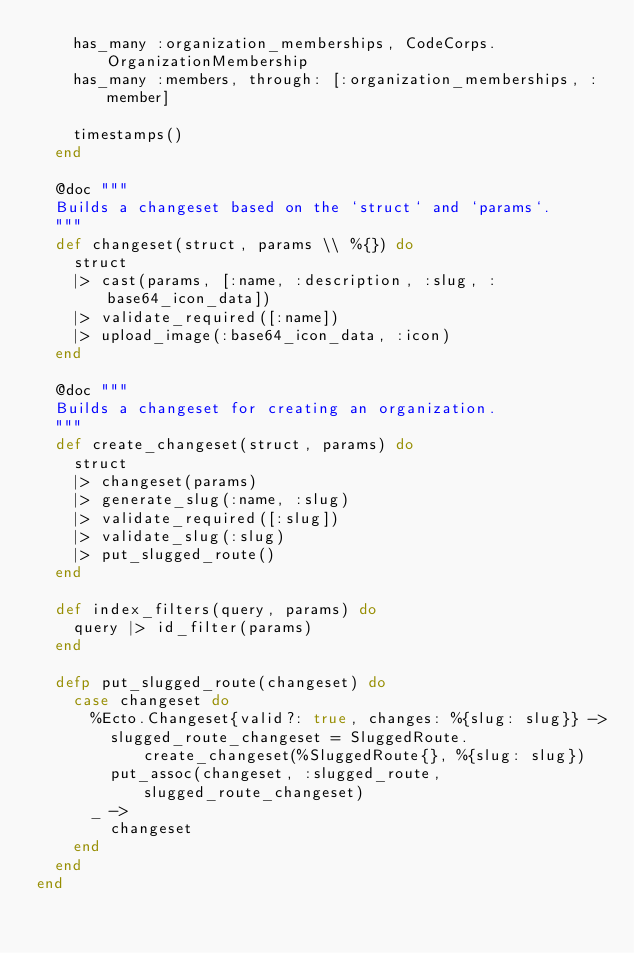<code> <loc_0><loc_0><loc_500><loc_500><_Elixir_>    has_many :organization_memberships, CodeCorps.OrganizationMembership
    has_many :members, through: [:organization_memberships, :member]

    timestamps()
  end

  @doc """
  Builds a changeset based on the `struct` and `params`.
  """
  def changeset(struct, params \\ %{}) do
    struct
    |> cast(params, [:name, :description, :slug, :base64_icon_data])
    |> validate_required([:name])
    |> upload_image(:base64_icon_data, :icon)
  end

  @doc """
  Builds a changeset for creating an organization.
  """
  def create_changeset(struct, params) do
    struct
    |> changeset(params)
    |> generate_slug(:name, :slug)
    |> validate_required([:slug])
    |> validate_slug(:slug)
    |> put_slugged_route()
  end

  def index_filters(query, params) do
    query |> id_filter(params)
  end

  defp put_slugged_route(changeset) do
    case changeset do
      %Ecto.Changeset{valid?: true, changes: %{slug: slug}} ->
        slugged_route_changeset = SluggedRoute.create_changeset(%SluggedRoute{}, %{slug: slug})
        put_assoc(changeset, :slugged_route, slugged_route_changeset)
      _ ->
        changeset
    end
  end
end
</code> 